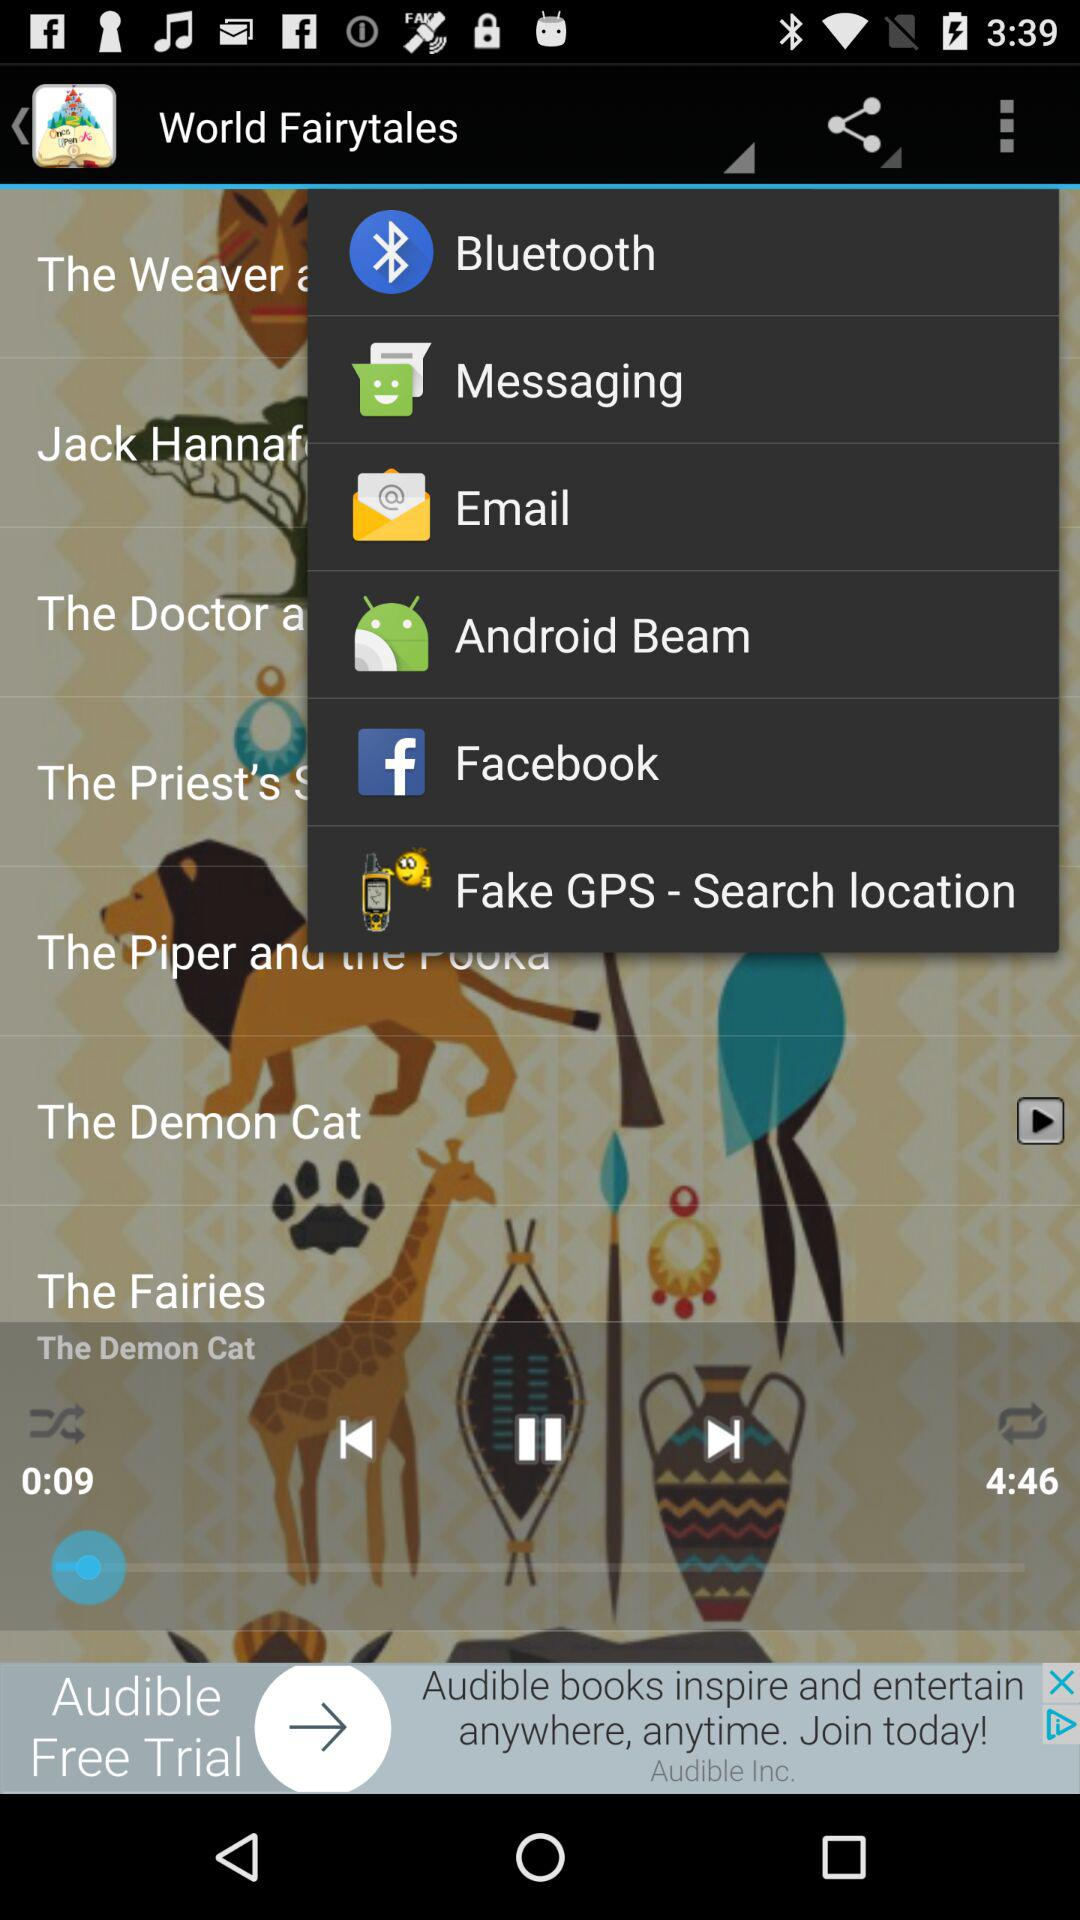Which audio is playing? The playing audio is "The Demon Cat". 